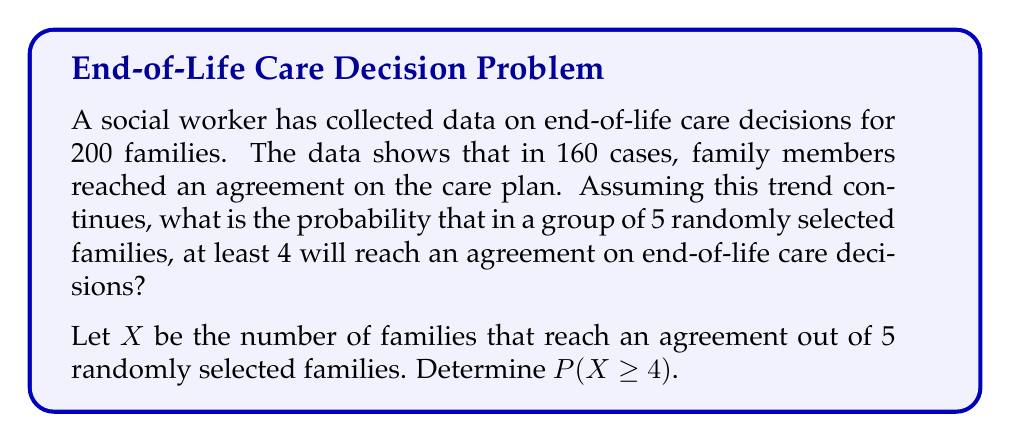Can you answer this question? Let's approach this step-by-step:

1) First, we need to calculate the probability of a single family reaching an agreement:
   $$p = \frac{160}{200} = 0.8$$

2) This scenario follows a binomial distribution with n = 5 trials and p = 0.8 probability of success.

3) We need to find P(X ≥ 4), which is equivalent to P(X = 4) + P(X = 5).

4) The probability mass function for a binomial distribution is:
   $$P(X = k) = \binom{n}{k} p^k (1-p)^{n-k}$$

5) For X = 4:
   $$P(X = 4) = \binom{5}{4} (0.8)^4 (0.2)^1 = 5 \cdot 0.4096 \cdot 0.2 = 0.4096$$

6) For X = 5:
   $$P(X = 5) = \binom{5}{5} (0.8)^5 (0.2)^0 = 1 \cdot 0.32768 = 0.32768$$

7) Therefore, P(X ≥ 4) = P(X = 4) + P(X = 5) = 0.4096 + 0.32768 = 0.73728
Answer: 0.73728 